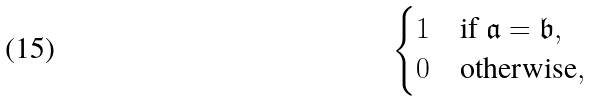Convert formula to latex. <formula><loc_0><loc_0><loc_500><loc_500>\begin{cases} 1 & \text {if\ } { \mathfrak a } = { \mathfrak b } , \\ 0 & \text {otherwise} , \end{cases}</formula> 